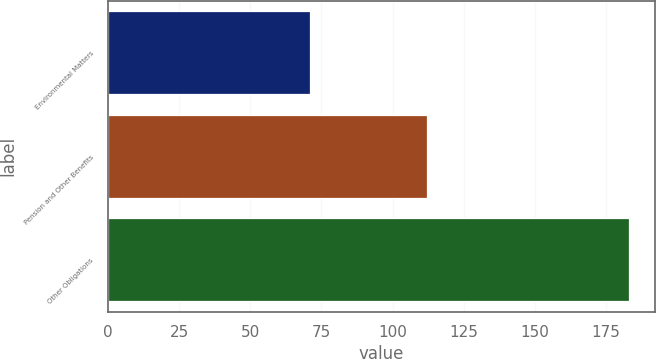Convert chart. <chart><loc_0><loc_0><loc_500><loc_500><bar_chart><fcel>Environmental Matters<fcel>Pension and Other Benefits<fcel>Other Obligations<nl><fcel>71<fcel>112<fcel>183<nl></chart> 